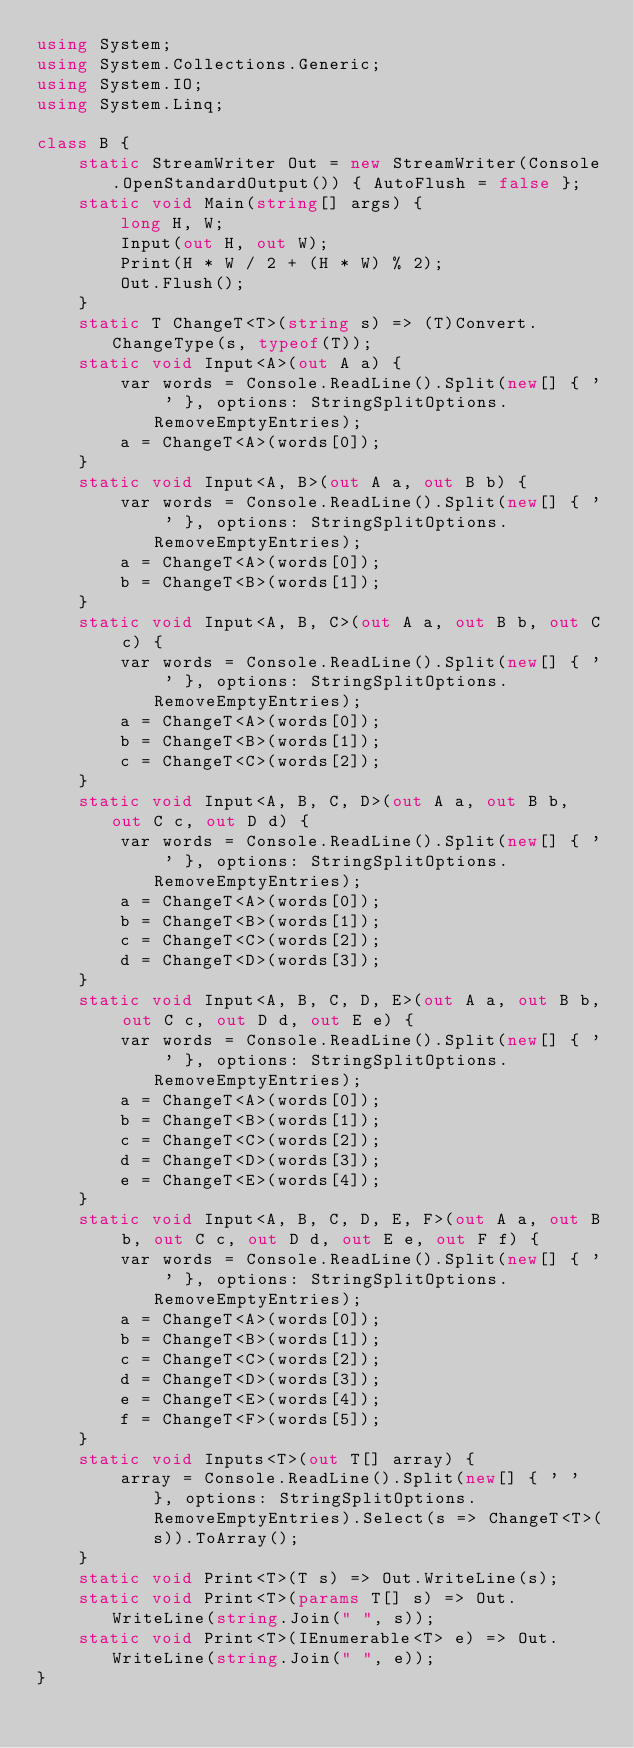<code> <loc_0><loc_0><loc_500><loc_500><_C#_>using System;
using System.Collections.Generic;
using System.IO;
using System.Linq;

class B {
    static StreamWriter Out = new StreamWriter(Console.OpenStandardOutput()) { AutoFlush = false };
    static void Main(string[] args) {
        long H, W;
        Input(out H, out W);
        Print(H * W / 2 + (H * W) % 2);
        Out.Flush();
    }
    static T ChangeT<T>(string s) => (T)Convert.ChangeType(s, typeof(T));
    static void Input<A>(out A a) {
        var words = Console.ReadLine().Split(new[] { ' ' }, options: StringSplitOptions.RemoveEmptyEntries);
        a = ChangeT<A>(words[0]);
    }
    static void Input<A, B>(out A a, out B b) {
        var words = Console.ReadLine().Split(new[] { ' ' }, options: StringSplitOptions.RemoveEmptyEntries);
        a = ChangeT<A>(words[0]);
        b = ChangeT<B>(words[1]);
    }
    static void Input<A, B, C>(out A a, out B b, out C c) {
        var words = Console.ReadLine().Split(new[] { ' ' }, options: StringSplitOptions.RemoveEmptyEntries);
        a = ChangeT<A>(words[0]);
        b = ChangeT<B>(words[1]);
        c = ChangeT<C>(words[2]);
    }
    static void Input<A, B, C, D>(out A a, out B b, out C c, out D d) {
        var words = Console.ReadLine().Split(new[] { ' ' }, options: StringSplitOptions.RemoveEmptyEntries);
        a = ChangeT<A>(words[0]);
        b = ChangeT<B>(words[1]);
        c = ChangeT<C>(words[2]);
        d = ChangeT<D>(words[3]);
    }
    static void Input<A, B, C, D, E>(out A a, out B b, out C c, out D d, out E e) {
        var words = Console.ReadLine().Split(new[] { ' ' }, options: StringSplitOptions.RemoveEmptyEntries);
        a = ChangeT<A>(words[0]);
        b = ChangeT<B>(words[1]);
        c = ChangeT<C>(words[2]);
        d = ChangeT<D>(words[3]);
        e = ChangeT<E>(words[4]);
    }
    static void Input<A, B, C, D, E, F>(out A a, out B b, out C c, out D d, out E e, out F f) {
        var words = Console.ReadLine().Split(new[] { ' ' }, options: StringSplitOptions.RemoveEmptyEntries);
        a = ChangeT<A>(words[0]);
        b = ChangeT<B>(words[1]);
        c = ChangeT<C>(words[2]);
        d = ChangeT<D>(words[3]);
        e = ChangeT<E>(words[4]);
        f = ChangeT<F>(words[5]);
    }
    static void Inputs<T>(out T[] array) {
        array = Console.ReadLine().Split(new[] { ' ' }, options: StringSplitOptions.RemoveEmptyEntries).Select(s => ChangeT<T>(s)).ToArray();
    }
    static void Print<T>(T s) => Out.WriteLine(s);
    static void Print<T>(params T[] s) => Out.WriteLine(string.Join(" ", s));
    static void Print<T>(IEnumerable<T> e) => Out.WriteLine(string.Join(" ", e));
}</code> 